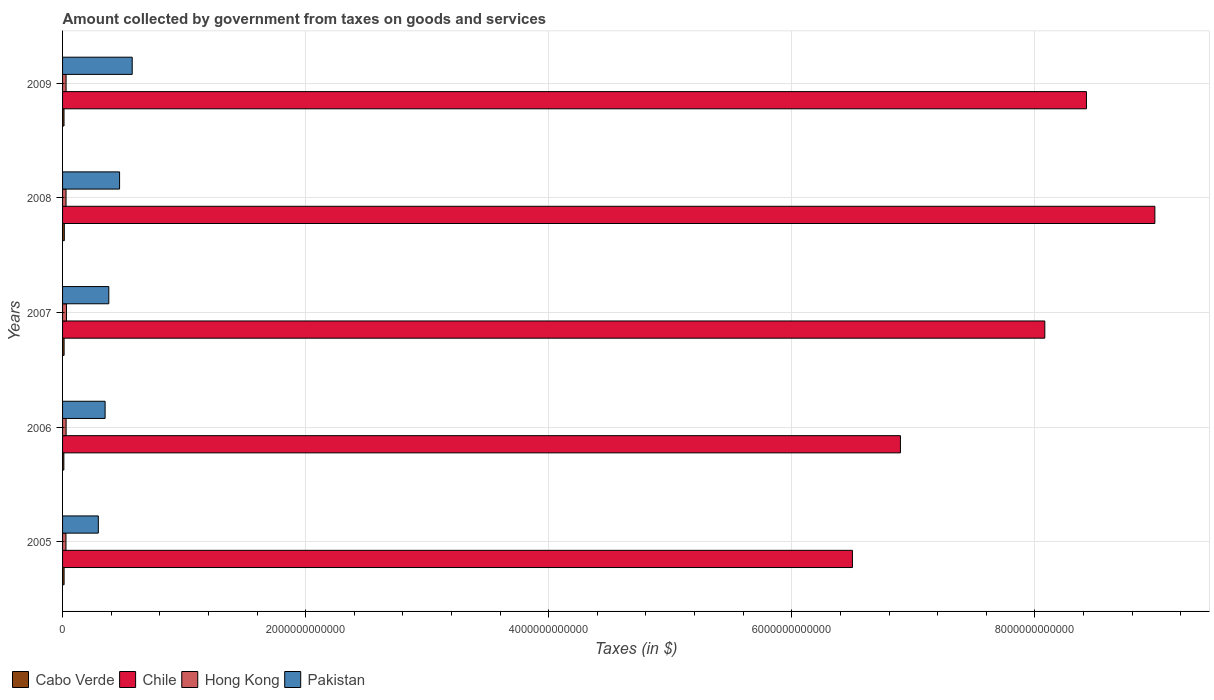How many different coloured bars are there?
Your answer should be compact. 4. How many groups of bars are there?
Ensure brevity in your answer.  5. Are the number of bars per tick equal to the number of legend labels?
Give a very brief answer. Yes. What is the label of the 2nd group of bars from the top?
Keep it short and to the point. 2008. In how many cases, is the number of bars for a given year not equal to the number of legend labels?
Your answer should be compact. 0. What is the amount collected by government from taxes on goods and services in Chile in 2008?
Your answer should be compact. 8.99e+12. Across all years, what is the maximum amount collected by government from taxes on goods and services in Cabo Verde?
Keep it short and to the point. 1.44e+1. Across all years, what is the minimum amount collected by government from taxes on goods and services in Cabo Verde?
Give a very brief answer. 1.06e+1. What is the total amount collected by government from taxes on goods and services in Pakistan in the graph?
Give a very brief answer. 2.07e+12. What is the difference between the amount collected by government from taxes on goods and services in Hong Kong in 2006 and that in 2009?
Your answer should be very brief. 3.08e+08. What is the difference between the amount collected by government from taxes on goods and services in Cabo Verde in 2006 and the amount collected by government from taxes on goods and services in Pakistan in 2007?
Ensure brevity in your answer.  -3.70e+11. What is the average amount collected by government from taxes on goods and services in Pakistan per year?
Provide a succinct answer. 4.13e+11. In the year 2009, what is the difference between the amount collected by government from taxes on goods and services in Chile and amount collected by government from taxes on goods and services in Pakistan?
Your answer should be very brief. 7.85e+12. What is the ratio of the amount collected by government from taxes on goods and services in Chile in 2005 to that in 2006?
Ensure brevity in your answer.  0.94. Is the amount collected by government from taxes on goods and services in Pakistan in 2007 less than that in 2008?
Provide a short and direct response. Yes. Is the difference between the amount collected by government from taxes on goods and services in Chile in 2005 and 2006 greater than the difference between the amount collected by government from taxes on goods and services in Pakistan in 2005 and 2006?
Your answer should be very brief. No. What is the difference between the highest and the second highest amount collected by government from taxes on goods and services in Hong Kong?
Provide a short and direct response. 2.78e+09. What is the difference between the highest and the lowest amount collected by government from taxes on goods and services in Chile?
Keep it short and to the point. 2.49e+12. In how many years, is the amount collected by government from taxes on goods and services in Chile greater than the average amount collected by government from taxes on goods and services in Chile taken over all years?
Your answer should be very brief. 3. Is the sum of the amount collected by government from taxes on goods and services in Cabo Verde in 2005 and 2006 greater than the maximum amount collected by government from taxes on goods and services in Hong Kong across all years?
Ensure brevity in your answer.  No. What does the 4th bar from the top in 2007 represents?
Offer a very short reply. Cabo Verde. What does the 2nd bar from the bottom in 2009 represents?
Your response must be concise. Chile. Is it the case that in every year, the sum of the amount collected by government from taxes on goods and services in Cabo Verde and amount collected by government from taxes on goods and services in Chile is greater than the amount collected by government from taxes on goods and services in Hong Kong?
Provide a short and direct response. Yes. How many years are there in the graph?
Keep it short and to the point. 5. What is the difference between two consecutive major ticks on the X-axis?
Your response must be concise. 2.00e+12. Does the graph contain grids?
Your answer should be very brief. Yes. Where does the legend appear in the graph?
Offer a terse response. Bottom left. What is the title of the graph?
Offer a very short reply. Amount collected by government from taxes on goods and services. Does "Korea (Democratic)" appear as one of the legend labels in the graph?
Keep it short and to the point. No. What is the label or title of the X-axis?
Give a very brief answer. Taxes (in $). What is the label or title of the Y-axis?
Ensure brevity in your answer.  Years. What is the Taxes (in $) of Cabo Verde in 2005?
Ensure brevity in your answer.  1.25e+1. What is the Taxes (in $) of Chile in 2005?
Ensure brevity in your answer.  6.50e+12. What is the Taxes (in $) in Hong Kong in 2005?
Keep it short and to the point. 2.80e+1. What is the Taxes (in $) in Pakistan in 2005?
Offer a very short reply. 2.94e+11. What is the Taxes (in $) of Cabo Verde in 2006?
Your answer should be very brief. 1.06e+1. What is the Taxes (in $) of Chile in 2006?
Provide a short and direct response. 6.89e+12. What is the Taxes (in $) in Hong Kong in 2006?
Your answer should be very brief. 2.92e+1. What is the Taxes (in $) of Pakistan in 2006?
Offer a terse response. 3.50e+11. What is the Taxes (in $) of Cabo Verde in 2007?
Provide a succinct answer. 1.26e+1. What is the Taxes (in $) in Chile in 2007?
Give a very brief answer. 8.08e+12. What is the Taxes (in $) in Hong Kong in 2007?
Your answer should be very brief. 3.20e+1. What is the Taxes (in $) in Pakistan in 2007?
Your answer should be very brief. 3.80e+11. What is the Taxes (in $) in Cabo Verde in 2008?
Provide a succinct answer. 1.44e+1. What is the Taxes (in $) of Chile in 2008?
Give a very brief answer. 8.99e+12. What is the Taxes (in $) in Hong Kong in 2008?
Provide a succinct answer. 2.85e+1. What is the Taxes (in $) in Pakistan in 2008?
Offer a terse response. 4.69e+11. What is the Taxes (in $) of Cabo Verde in 2009?
Make the answer very short. 1.19e+1. What is the Taxes (in $) in Chile in 2009?
Give a very brief answer. 8.42e+12. What is the Taxes (in $) of Hong Kong in 2009?
Your response must be concise. 2.89e+1. What is the Taxes (in $) in Pakistan in 2009?
Give a very brief answer. 5.73e+11. Across all years, what is the maximum Taxes (in $) of Cabo Verde?
Offer a terse response. 1.44e+1. Across all years, what is the maximum Taxes (in $) of Chile?
Offer a very short reply. 8.99e+12. Across all years, what is the maximum Taxes (in $) in Hong Kong?
Make the answer very short. 3.20e+1. Across all years, what is the maximum Taxes (in $) in Pakistan?
Offer a terse response. 5.73e+11. Across all years, what is the minimum Taxes (in $) in Cabo Verde?
Keep it short and to the point. 1.06e+1. Across all years, what is the minimum Taxes (in $) in Chile?
Keep it short and to the point. 6.50e+12. Across all years, what is the minimum Taxes (in $) of Hong Kong?
Give a very brief answer. 2.80e+1. Across all years, what is the minimum Taxes (in $) of Pakistan?
Provide a short and direct response. 2.94e+11. What is the total Taxes (in $) in Cabo Verde in the graph?
Offer a very short reply. 6.21e+1. What is the total Taxes (in $) in Chile in the graph?
Your answer should be compact. 3.89e+13. What is the total Taxes (in $) in Hong Kong in the graph?
Ensure brevity in your answer.  1.47e+11. What is the total Taxes (in $) of Pakistan in the graph?
Keep it short and to the point. 2.07e+12. What is the difference between the Taxes (in $) in Cabo Verde in 2005 and that in 2006?
Provide a short and direct response. 1.93e+09. What is the difference between the Taxes (in $) in Chile in 2005 and that in 2006?
Make the answer very short. -3.95e+11. What is the difference between the Taxes (in $) of Hong Kong in 2005 and that in 2006?
Provide a succinct answer. -1.18e+09. What is the difference between the Taxes (in $) in Pakistan in 2005 and that in 2006?
Offer a very short reply. -5.59e+1. What is the difference between the Taxes (in $) in Cabo Verde in 2005 and that in 2007?
Offer a very short reply. -6.90e+07. What is the difference between the Taxes (in $) of Chile in 2005 and that in 2007?
Offer a terse response. -1.58e+12. What is the difference between the Taxes (in $) in Hong Kong in 2005 and that in 2007?
Provide a short and direct response. -3.97e+09. What is the difference between the Taxes (in $) in Pakistan in 2005 and that in 2007?
Provide a succinct answer. -8.63e+1. What is the difference between the Taxes (in $) of Cabo Verde in 2005 and that in 2008?
Provide a short and direct response. -1.86e+09. What is the difference between the Taxes (in $) in Chile in 2005 and that in 2008?
Your answer should be very brief. -2.49e+12. What is the difference between the Taxes (in $) of Hong Kong in 2005 and that in 2008?
Your answer should be compact. -4.55e+08. What is the difference between the Taxes (in $) of Pakistan in 2005 and that in 2008?
Your response must be concise. -1.75e+11. What is the difference between the Taxes (in $) in Cabo Verde in 2005 and that in 2009?
Give a very brief answer. 6.39e+08. What is the difference between the Taxes (in $) of Chile in 2005 and that in 2009?
Your answer should be very brief. -1.93e+12. What is the difference between the Taxes (in $) in Hong Kong in 2005 and that in 2009?
Ensure brevity in your answer.  -8.77e+08. What is the difference between the Taxes (in $) in Pakistan in 2005 and that in 2009?
Your answer should be compact. -2.79e+11. What is the difference between the Taxes (in $) of Cabo Verde in 2006 and that in 2007?
Your answer should be very brief. -2.00e+09. What is the difference between the Taxes (in $) of Chile in 2006 and that in 2007?
Provide a succinct answer. -1.19e+12. What is the difference between the Taxes (in $) of Hong Kong in 2006 and that in 2007?
Offer a very short reply. -2.78e+09. What is the difference between the Taxes (in $) in Pakistan in 2006 and that in 2007?
Provide a short and direct response. -3.04e+1. What is the difference between the Taxes (in $) in Cabo Verde in 2006 and that in 2008?
Give a very brief answer. -3.79e+09. What is the difference between the Taxes (in $) of Chile in 2006 and that in 2008?
Make the answer very short. -2.09e+12. What is the difference between the Taxes (in $) in Hong Kong in 2006 and that in 2008?
Ensure brevity in your answer.  7.30e+08. What is the difference between the Taxes (in $) in Pakistan in 2006 and that in 2008?
Your answer should be compact. -1.19e+11. What is the difference between the Taxes (in $) of Cabo Verde in 2006 and that in 2009?
Your answer should be compact. -1.29e+09. What is the difference between the Taxes (in $) of Chile in 2006 and that in 2009?
Ensure brevity in your answer.  -1.53e+12. What is the difference between the Taxes (in $) in Hong Kong in 2006 and that in 2009?
Make the answer very short. 3.08e+08. What is the difference between the Taxes (in $) of Pakistan in 2006 and that in 2009?
Give a very brief answer. -2.23e+11. What is the difference between the Taxes (in $) of Cabo Verde in 2007 and that in 2008?
Make the answer very short. -1.79e+09. What is the difference between the Taxes (in $) in Chile in 2007 and that in 2008?
Your answer should be very brief. -9.06e+11. What is the difference between the Taxes (in $) of Hong Kong in 2007 and that in 2008?
Offer a terse response. 3.51e+09. What is the difference between the Taxes (in $) in Pakistan in 2007 and that in 2008?
Ensure brevity in your answer.  -8.86e+1. What is the difference between the Taxes (in $) in Cabo Verde in 2007 and that in 2009?
Offer a very short reply. 7.08e+08. What is the difference between the Taxes (in $) in Chile in 2007 and that in 2009?
Keep it short and to the point. -3.43e+11. What is the difference between the Taxes (in $) of Hong Kong in 2007 and that in 2009?
Offer a terse response. 3.09e+09. What is the difference between the Taxes (in $) of Pakistan in 2007 and that in 2009?
Offer a very short reply. -1.93e+11. What is the difference between the Taxes (in $) in Cabo Verde in 2008 and that in 2009?
Ensure brevity in your answer.  2.50e+09. What is the difference between the Taxes (in $) in Chile in 2008 and that in 2009?
Your answer should be compact. 5.63e+11. What is the difference between the Taxes (in $) of Hong Kong in 2008 and that in 2009?
Your answer should be compact. -4.22e+08. What is the difference between the Taxes (in $) in Pakistan in 2008 and that in 2009?
Provide a short and direct response. -1.04e+11. What is the difference between the Taxes (in $) of Cabo Verde in 2005 and the Taxes (in $) of Chile in 2006?
Provide a short and direct response. -6.88e+12. What is the difference between the Taxes (in $) of Cabo Verde in 2005 and the Taxes (in $) of Hong Kong in 2006?
Provide a succinct answer. -1.67e+1. What is the difference between the Taxes (in $) in Cabo Verde in 2005 and the Taxes (in $) in Pakistan in 2006?
Provide a succinct answer. -3.38e+11. What is the difference between the Taxes (in $) of Chile in 2005 and the Taxes (in $) of Hong Kong in 2006?
Offer a very short reply. 6.47e+12. What is the difference between the Taxes (in $) in Chile in 2005 and the Taxes (in $) in Pakistan in 2006?
Your answer should be compact. 6.15e+12. What is the difference between the Taxes (in $) of Hong Kong in 2005 and the Taxes (in $) of Pakistan in 2006?
Make the answer very short. -3.22e+11. What is the difference between the Taxes (in $) in Cabo Verde in 2005 and the Taxes (in $) in Chile in 2007?
Keep it short and to the point. -8.07e+12. What is the difference between the Taxes (in $) in Cabo Verde in 2005 and the Taxes (in $) in Hong Kong in 2007?
Your response must be concise. -1.94e+1. What is the difference between the Taxes (in $) in Cabo Verde in 2005 and the Taxes (in $) in Pakistan in 2007?
Make the answer very short. -3.68e+11. What is the difference between the Taxes (in $) in Chile in 2005 and the Taxes (in $) in Hong Kong in 2007?
Offer a very short reply. 6.47e+12. What is the difference between the Taxes (in $) in Chile in 2005 and the Taxes (in $) in Pakistan in 2007?
Give a very brief answer. 6.12e+12. What is the difference between the Taxes (in $) of Hong Kong in 2005 and the Taxes (in $) of Pakistan in 2007?
Provide a short and direct response. -3.52e+11. What is the difference between the Taxes (in $) in Cabo Verde in 2005 and the Taxes (in $) in Chile in 2008?
Provide a succinct answer. -8.97e+12. What is the difference between the Taxes (in $) of Cabo Verde in 2005 and the Taxes (in $) of Hong Kong in 2008?
Keep it short and to the point. -1.59e+1. What is the difference between the Taxes (in $) in Cabo Verde in 2005 and the Taxes (in $) in Pakistan in 2008?
Offer a terse response. -4.57e+11. What is the difference between the Taxes (in $) in Chile in 2005 and the Taxes (in $) in Hong Kong in 2008?
Provide a succinct answer. 6.47e+12. What is the difference between the Taxes (in $) of Chile in 2005 and the Taxes (in $) of Pakistan in 2008?
Provide a short and direct response. 6.03e+12. What is the difference between the Taxes (in $) in Hong Kong in 2005 and the Taxes (in $) in Pakistan in 2008?
Keep it short and to the point. -4.41e+11. What is the difference between the Taxes (in $) of Cabo Verde in 2005 and the Taxes (in $) of Chile in 2009?
Offer a very short reply. -8.41e+12. What is the difference between the Taxes (in $) in Cabo Verde in 2005 and the Taxes (in $) in Hong Kong in 2009?
Give a very brief answer. -1.63e+1. What is the difference between the Taxes (in $) in Cabo Verde in 2005 and the Taxes (in $) in Pakistan in 2009?
Your response must be concise. -5.60e+11. What is the difference between the Taxes (in $) of Chile in 2005 and the Taxes (in $) of Hong Kong in 2009?
Your answer should be compact. 6.47e+12. What is the difference between the Taxes (in $) in Chile in 2005 and the Taxes (in $) in Pakistan in 2009?
Keep it short and to the point. 5.93e+12. What is the difference between the Taxes (in $) of Hong Kong in 2005 and the Taxes (in $) of Pakistan in 2009?
Keep it short and to the point. -5.45e+11. What is the difference between the Taxes (in $) of Cabo Verde in 2006 and the Taxes (in $) of Chile in 2007?
Keep it short and to the point. -8.07e+12. What is the difference between the Taxes (in $) in Cabo Verde in 2006 and the Taxes (in $) in Hong Kong in 2007?
Give a very brief answer. -2.14e+1. What is the difference between the Taxes (in $) of Cabo Verde in 2006 and the Taxes (in $) of Pakistan in 2007?
Keep it short and to the point. -3.70e+11. What is the difference between the Taxes (in $) of Chile in 2006 and the Taxes (in $) of Hong Kong in 2007?
Keep it short and to the point. 6.86e+12. What is the difference between the Taxes (in $) in Chile in 2006 and the Taxes (in $) in Pakistan in 2007?
Ensure brevity in your answer.  6.51e+12. What is the difference between the Taxes (in $) in Hong Kong in 2006 and the Taxes (in $) in Pakistan in 2007?
Offer a terse response. -3.51e+11. What is the difference between the Taxes (in $) of Cabo Verde in 2006 and the Taxes (in $) of Chile in 2008?
Make the answer very short. -8.98e+12. What is the difference between the Taxes (in $) of Cabo Verde in 2006 and the Taxes (in $) of Hong Kong in 2008?
Your response must be concise. -1.79e+1. What is the difference between the Taxes (in $) in Cabo Verde in 2006 and the Taxes (in $) in Pakistan in 2008?
Make the answer very short. -4.58e+11. What is the difference between the Taxes (in $) in Chile in 2006 and the Taxes (in $) in Hong Kong in 2008?
Keep it short and to the point. 6.87e+12. What is the difference between the Taxes (in $) of Chile in 2006 and the Taxes (in $) of Pakistan in 2008?
Your answer should be compact. 6.42e+12. What is the difference between the Taxes (in $) in Hong Kong in 2006 and the Taxes (in $) in Pakistan in 2008?
Ensure brevity in your answer.  -4.40e+11. What is the difference between the Taxes (in $) of Cabo Verde in 2006 and the Taxes (in $) of Chile in 2009?
Offer a very short reply. -8.41e+12. What is the difference between the Taxes (in $) of Cabo Verde in 2006 and the Taxes (in $) of Hong Kong in 2009?
Provide a short and direct response. -1.83e+1. What is the difference between the Taxes (in $) in Cabo Verde in 2006 and the Taxes (in $) in Pakistan in 2009?
Offer a very short reply. -5.62e+11. What is the difference between the Taxes (in $) of Chile in 2006 and the Taxes (in $) of Hong Kong in 2009?
Provide a succinct answer. 6.87e+12. What is the difference between the Taxes (in $) of Chile in 2006 and the Taxes (in $) of Pakistan in 2009?
Offer a terse response. 6.32e+12. What is the difference between the Taxes (in $) in Hong Kong in 2006 and the Taxes (in $) in Pakistan in 2009?
Your answer should be compact. -5.44e+11. What is the difference between the Taxes (in $) of Cabo Verde in 2007 and the Taxes (in $) of Chile in 2008?
Offer a very short reply. -8.97e+12. What is the difference between the Taxes (in $) in Cabo Verde in 2007 and the Taxes (in $) in Hong Kong in 2008?
Offer a very short reply. -1.59e+1. What is the difference between the Taxes (in $) of Cabo Verde in 2007 and the Taxes (in $) of Pakistan in 2008?
Offer a very short reply. -4.56e+11. What is the difference between the Taxes (in $) in Chile in 2007 and the Taxes (in $) in Hong Kong in 2008?
Offer a terse response. 8.05e+12. What is the difference between the Taxes (in $) in Chile in 2007 and the Taxes (in $) in Pakistan in 2008?
Your answer should be compact. 7.61e+12. What is the difference between the Taxes (in $) in Hong Kong in 2007 and the Taxes (in $) in Pakistan in 2008?
Give a very brief answer. -4.37e+11. What is the difference between the Taxes (in $) in Cabo Verde in 2007 and the Taxes (in $) in Chile in 2009?
Provide a succinct answer. -8.41e+12. What is the difference between the Taxes (in $) of Cabo Verde in 2007 and the Taxes (in $) of Hong Kong in 2009?
Your response must be concise. -1.63e+1. What is the difference between the Taxes (in $) in Cabo Verde in 2007 and the Taxes (in $) in Pakistan in 2009?
Your response must be concise. -5.60e+11. What is the difference between the Taxes (in $) in Chile in 2007 and the Taxes (in $) in Hong Kong in 2009?
Ensure brevity in your answer.  8.05e+12. What is the difference between the Taxes (in $) of Chile in 2007 and the Taxes (in $) of Pakistan in 2009?
Ensure brevity in your answer.  7.51e+12. What is the difference between the Taxes (in $) of Hong Kong in 2007 and the Taxes (in $) of Pakistan in 2009?
Your answer should be compact. -5.41e+11. What is the difference between the Taxes (in $) of Cabo Verde in 2008 and the Taxes (in $) of Chile in 2009?
Offer a terse response. -8.41e+12. What is the difference between the Taxes (in $) in Cabo Verde in 2008 and the Taxes (in $) in Hong Kong in 2009?
Give a very brief answer. -1.45e+1. What is the difference between the Taxes (in $) in Cabo Verde in 2008 and the Taxes (in $) in Pakistan in 2009?
Provide a short and direct response. -5.59e+11. What is the difference between the Taxes (in $) of Chile in 2008 and the Taxes (in $) of Hong Kong in 2009?
Offer a very short reply. 8.96e+12. What is the difference between the Taxes (in $) in Chile in 2008 and the Taxes (in $) in Pakistan in 2009?
Your answer should be very brief. 8.41e+12. What is the difference between the Taxes (in $) in Hong Kong in 2008 and the Taxes (in $) in Pakistan in 2009?
Your response must be concise. -5.45e+11. What is the average Taxes (in $) of Cabo Verde per year?
Give a very brief answer. 1.24e+1. What is the average Taxes (in $) of Chile per year?
Your answer should be compact. 7.78e+12. What is the average Taxes (in $) of Hong Kong per year?
Make the answer very short. 2.93e+1. What is the average Taxes (in $) of Pakistan per year?
Offer a very short reply. 4.13e+11. In the year 2005, what is the difference between the Taxes (in $) of Cabo Verde and Taxes (in $) of Chile?
Offer a very short reply. -6.49e+12. In the year 2005, what is the difference between the Taxes (in $) of Cabo Verde and Taxes (in $) of Hong Kong?
Your answer should be compact. -1.55e+1. In the year 2005, what is the difference between the Taxes (in $) in Cabo Verde and Taxes (in $) in Pakistan?
Your answer should be very brief. -2.82e+11. In the year 2005, what is the difference between the Taxes (in $) of Chile and Taxes (in $) of Hong Kong?
Keep it short and to the point. 6.47e+12. In the year 2005, what is the difference between the Taxes (in $) of Chile and Taxes (in $) of Pakistan?
Offer a terse response. 6.20e+12. In the year 2005, what is the difference between the Taxes (in $) in Hong Kong and Taxes (in $) in Pakistan?
Provide a short and direct response. -2.66e+11. In the year 2006, what is the difference between the Taxes (in $) of Cabo Verde and Taxes (in $) of Chile?
Make the answer very short. -6.88e+12. In the year 2006, what is the difference between the Taxes (in $) in Cabo Verde and Taxes (in $) in Hong Kong?
Offer a terse response. -1.86e+1. In the year 2006, what is the difference between the Taxes (in $) in Cabo Verde and Taxes (in $) in Pakistan?
Your response must be concise. -3.39e+11. In the year 2006, what is the difference between the Taxes (in $) of Chile and Taxes (in $) of Hong Kong?
Provide a succinct answer. 6.86e+12. In the year 2006, what is the difference between the Taxes (in $) in Chile and Taxes (in $) in Pakistan?
Provide a succinct answer. 6.54e+12. In the year 2006, what is the difference between the Taxes (in $) of Hong Kong and Taxes (in $) of Pakistan?
Give a very brief answer. -3.21e+11. In the year 2007, what is the difference between the Taxes (in $) of Cabo Verde and Taxes (in $) of Chile?
Provide a succinct answer. -8.07e+12. In the year 2007, what is the difference between the Taxes (in $) of Cabo Verde and Taxes (in $) of Hong Kong?
Offer a very short reply. -1.94e+1. In the year 2007, what is the difference between the Taxes (in $) of Cabo Verde and Taxes (in $) of Pakistan?
Make the answer very short. -3.68e+11. In the year 2007, what is the difference between the Taxes (in $) in Chile and Taxes (in $) in Hong Kong?
Your answer should be very brief. 8.05e+12. In the year 2007, what is the difference between the Taxes (in $) in Chile and Taxes (in $) in Pakistan?
Give a very brief answer. 7.70e+12. In the year 2007, what is the difference between the Taxes (in $) in Hong Kong and Taxes (in $) in Pakistan?
Offer a very short reply. -3.49e+11. In the year 2008, what is the difference between the Taxes (in $) of Cabo Verde and Taxes (in $) of Chile?
Offer a very short reply. -8.97e+12. In the year 2008, what is the difference between the Taxes (in $) of Cabo Verde and Taxes (in $) of Hong Kong?
Your response must be concise. -1.41e+1. In the year 2008, what is the difference between the Taxes (in $) in Cabo Verde and Taxes (in $) in Pakistan?
Ensure brevity in your answer.  -4.55e+11. In the year 2008, what is the difference between the Taxes (in $) in Chile and Taxes (in $) in Hong Kong?
Your answer should be very brief. 8.96e+12. In the year 2008, what is the difference between the Taxes (in $) of Chile and Taxes (in $) of Pakistan?
Offer a terse response. 8.52e+12. In the year 2008, what is the difference between the Taxes (in $) in Hong Kong and Taxes (in $) in Pakistan?
Your answer should be very brief. -4.41e+11. In the year 2009, what is the difference between the Taxes (in $) in Cabo Verde and Taxes (in $) in Chile?
Your answer should be very brief. -8.41e+12. In the year 2009, what is the difference between the Taxes (in $) of Cabo Verde and Taxes (in $) of Hong Kong?
Keep it short and to the point. -1.70e+1. In the year 2009, what is the difference between the Taxes (in $) in Cabo Verde and Taxes (in $) in Pakistan?
Your response must be concise. -5.61e+11. In the year 2009, what is the difference between the Taxes (in $) in Chile and Taxes (in $) in Hong Kong?
Keep it short and to the point. 8.40e+12. In the year 2009, what is the difference between the Taxes (in $) of Chile and Taxes (in $) of Pakistan?
Provide a succinct answer. 7.85e+12. In the year 2009, what is the difference between the Taxes (in $) in Hong Kong and Taxes (in $) in Pakistan?
Provide a short and direct response. -5.44e+11. What is the ratio of the Taxes (in $) of Cabo Verde in 2005 to that in 2006?
Ensure brevity in your answer.  1.18. What is the ratio of the Taxes (in $) of Chile in 2005 to that in 2006?
Your answer should be compact. 0.94. What is the ratio of the Taxes (in $) of Hong Kong in 2005 to that in 2006?
Your answer should be very brief. 0.96. What is the ratio of the Taxes (in $) of Pakistan in 2005 to that in 2006?
Your answer should be very brief. 0.84. What is the ratio of the Taxes (in $) in Chile in 2005 to that in 2007?
Offer a very short reply. 0.8. What is the ratio of the Taxes (in $) in Hong Kong in 2005 to that in 2007?
Your response must be concise. 0.88. What is the ratio of the Taxes (in $) of Pakistan in 2005 to that in 2007?
Ensure brevity in your answer.  0.77. What is the ratio of the Taxes (in $) in Cabo Verde in 2005 to that in 2008?
Offer a very short reply. 0.87. What is the ratio of the Taxes (in $) of Chile in 2005 to that in 2008?
Make the answer very short. 0.72. What is the ratio of the Taxes (in $) in Pakistan in 2005 to that in 2008?
Ensure brevity in your answer.  0.63. What is the ratio of the Taxes (in $) of Cabo Verde in 2005 to that in 2009?
Keep it short and to the point. 1.05. What is the ratio of the Taxes (in $) in Chile in 2005 to that in 2009?
Make the answer very short. 0.77. What is the ratio of the Taxes (in $) in Hong Kong in 2005 to that in 2009?
Provide a short and direct response. 0.97. What is the ratio of the Taxes (in $) of Pakistan in 2005 to that in 2009?
Your answer should be compact. 0.51. What is the ratio of the Taxes (in $) of Cabo Verde in 2006 to that in 2007?
Keep it short and to the point. 0.84. What is the ratio of the Taxes (in $) of Chile in 2006 to that in 2007?
Your answer should be very brief. 0.85. What is the ratio of the Taxes (in $) in Pakistan in 2006 to that in 2007?
Give a very brief answer. 0.92. What is the ratio of the Taxes (in $) of Cabo Verde in 2006 to that in 2008?
Offer a terse response. 0.74. What is the ratio of the Taxes (in $) of Chile in 2006 to that in 2008?
Give a very brief answer. 0.77. What is the ratio of the Taxes (in $) in Hong Kong in 2006 to that in 2008?
Offer a very short reply. 1.03. What is the ratio of the Taxes (in $) of Pakistan in 2006 to that in 2008?
Make the answer very short. 0.75. What is the ratio of the Taxes (in $) in Cabo Verde in 2006 to that in 2009?
Offer a very short reply. 0.89. What is the ratio of the Taxes (in $) of Chile in 2006 to that in 2009?
Provide a short and direct response. 0.82. What is the ratio of the Taxes (in $) of Hong Kong in 2006 to that in 2009?
Offer a terse response. 1.01. What is the ratio of the Taxes (in $) of Pakistan in 2006 to that in 2009?
Provide a succinct answer. 0.61. What is the ratio of the Taxes (in $) in Cabo Verde in 2007 to that in 2008?
Your answer should be very brief. 0.88. What is the ratio of the Taxes (in $) in Chile in 2007 to that in 2008?
Keep it short and to the point. 0.9. What is the ratio of the Taxes (in $) in Hong Kong in 2007 to that in 2008?
Ensure brevity in your answer.  1.12. What is the ratio of the Taxes (in $) in Pakistan in 2007 to that in 2008?
Offer a terse response. 0.81. What is the ratio of the Taxes (in $) in Cabo Verde in 2007 to that in 2009?
Ensure brevity in your answer.  1.06. What is the ratio of the Taxes (in $) in Chile in 2007 to that in 2009?
Provide a short and direct response. 0.96. What is the ratio of the Taxes (in $) in Hong Kong in 2007 to that in 2009?
Offer a very short reply. 1.11. What is the ratio of the Taxes (in $) of Pakistan in 2007 to that in 2009?
Give a very brief answer. 0.66. What is the ratio of the Taxes (in $) in Cabo Verde in 2008 to that in 2009?
Provide a succinct answer. 1.21. What is the ratio of the Taxes (in $) in Chile in 2008 to that in 2009?
Ensure brevity in your answer.  1.07. What is the ratio of the Taxes (in $) of Hong Kong in 2008 to that in 2009?
Keep it short and to the point. 0.99. What is the ratio of the Taxes (in $) in Pakistan in 2008 to that in 2009?
Make the answer very short. 0.82. What is the difference between the highest and the second highest Taxes (in $) in Cabo Verde?
Your response must be concise. 1.79e+09. What is the difference between the highest and the second highest Taxes (in $) of Chile?
Provide a succinct answer. 5.63e+11. What is the difference between the highest and the second highest Taxes (in $) of Hong Kong?
Offer a terse response. 2.78e+09. What is the difference between the highest and the second highest Taxes (in $) in Pakistan?
Ensure brevity in your answer.  1.04e+11. What is the difference between the highest and the lowest Taxes (in $) in Cabo Verde?
Provide a short and direct response. 3.79e+09. What is the difference between the highest and the lowest Taxes (in $) of Chile?
Provide a succinct answer. 2.49e+12. What is the difference between the highest and the lowest Taxes (in $) in Hong Kong?
Provide a succinct answer. 3.97e+09. What is the difference between the highest and the lowest Taxes (in $) in Pakistan?
Give a very brief answer. 2.79e+11. 